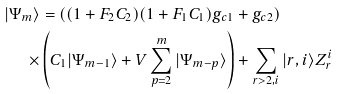<formula> <loc_0><loc_0><loc_500><loc_500>| \Psi _ { m } \rangle & = \left ( ( 1 + F _ { 2 } C _ { 2 } ) ( 1 + F _ { 1 } C _ { 1 } ) g _ { c 1 } + g _ { c 2 } \right ) \\ \times & \left ( C _ { 1 } | \Psi _ { m - 1 } \rangle + V \sum _ { p = 2 } ^ { m } | \Psi _ { m - p } \rangle \right ) + \sum _ { r > 2 , i } | r , i \rangle Z _ { r } ^ { i }</formula> 